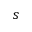Convert formula to latex. <formula><loc_0><loc_0><loc_500><loc_500>s</formula> 